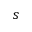Convert formula to latex. <formula><loc_0><loc_0><loc_500><loc_500>s</formula> 